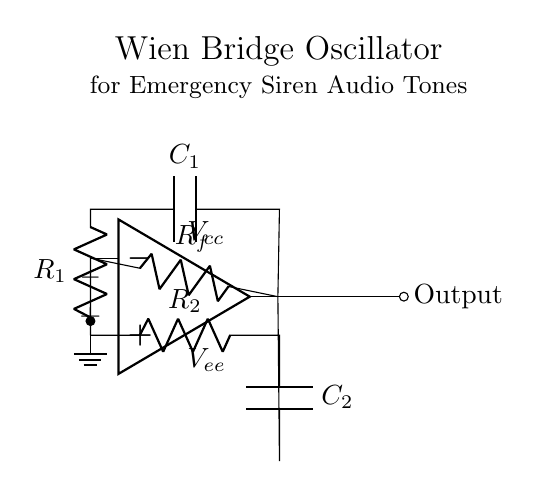What type of oscillator is this? The circuit diagram represents a Wien Bridge Oscillator, which is specifically designed to generate sine wave oscillations. This can be identified by the arrangement of resistors and capacitors in the feedback loop.
Answer: Wien Bridge Oscillator What is the purpose of the resistors and capacitors in this circuit? The resistors and capacitors in a Wien Bridge Oscillator determine the frequency of oscillation by creating a specific feedback loop. The values of R1, R2, C1, and C2 are crucial for setting the oscillation frequency, which is derived from their combination.
Answer: Frequency determination Which components provide positive feedback? The positive feedback is provided by the combination of R1 and C1, as they connect the output of the op-amp back to its non-inverting input. This is part of the regenerative feedback required for oscillation.
Answer: R1 and C1 What does the feedback resistor do in this circuit? The feedback resistor, labeled as Rf, stabilizes the amplitude of the oscillation by controlling the gain of the op-amp in this oscillator configuration. It ensures that the output signal does not grow indefinitely.
Answer: Amplitude stabilization What would happen if the values of R1 and R2 were equal? If R1 and R2 are equal, the condition for oscillation frequency is met, causing potential instability, which can lead to oscillations at a frequency determined only by Rf and the capacitors. This is a unique trait of the Wien Bridge design.
Answer: Oscillation instability What is the output nature from this oscillator? The output from a Wien Bridge Oscillator generates a sine wave signal. This characteristic makes it suitable for applications such as generating audio tones for alarms and emergency sirens.
Answer: Sine wave signal 